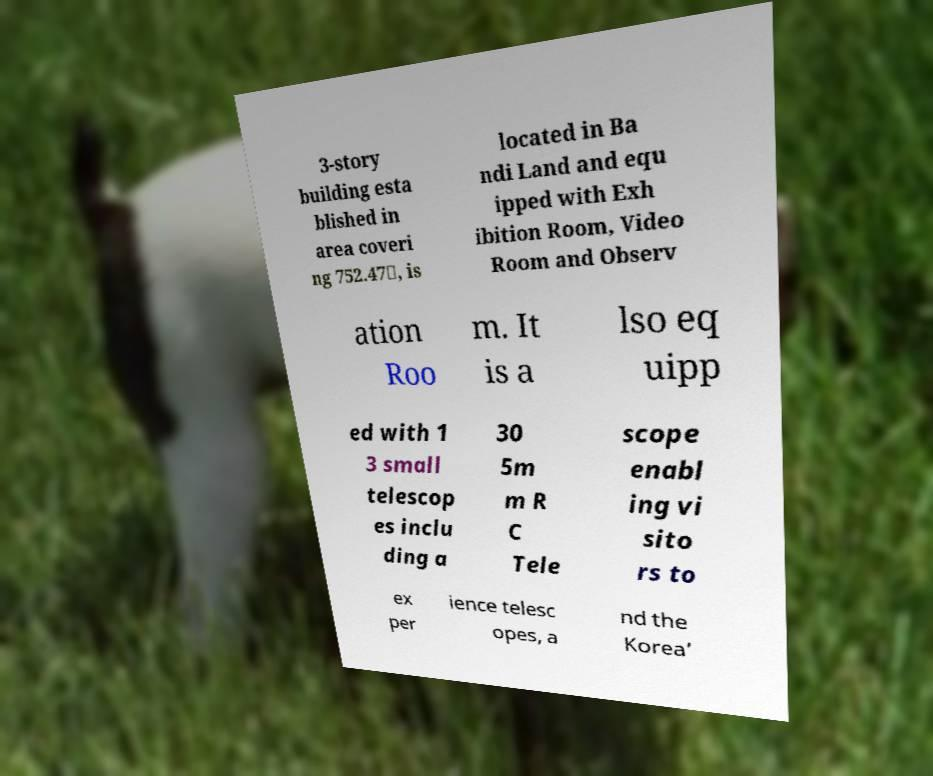For documentation purposes, I need the text within this image transcribed. Could you provide that? 3-story building esta blished in area coveri ng 752.47㎡, is located in Ba ndi Land and equ ipped with Exh ibition Room, Video Room and Observ ation Roo m. It is a lso eq uipp ed with 1 3 small telescop es inclu ding a 30 5m m R C Tele scope enabl ing vi sito rs to ex per ience telesc opes, a nd the Korea’ 